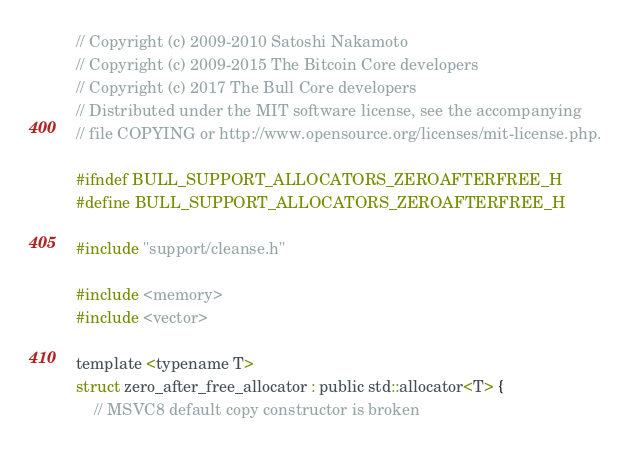<code> <loc_0><loc_0><loc_500><loc_500><_C_>// Copyright (c) 2009-2010 Satoshi Nakamoto
// Copyright (c) 2009-2015 The Bitcoin Core developers
// Copyright (c) 2017 The Bull Core developers
// Distributed under the MIT software license, see the accompanying
// file COPYING or http://www.opensource.org/licenses/mit-license.php.

#ifndef BULL_SUPPORT_ALLOCATORS_ZEROAFTERFREE_H
#define BULL_SUPPORT_ALLOCATORS_ZEROAFTERFREE_H

#include "support/cleanse.h"

#include <memory>
#include <vector>

template <typename T>
struct zero_after_free_allocator : public std::allocator<T> {
    // MSVC8 default copy constructor is broken</code> 